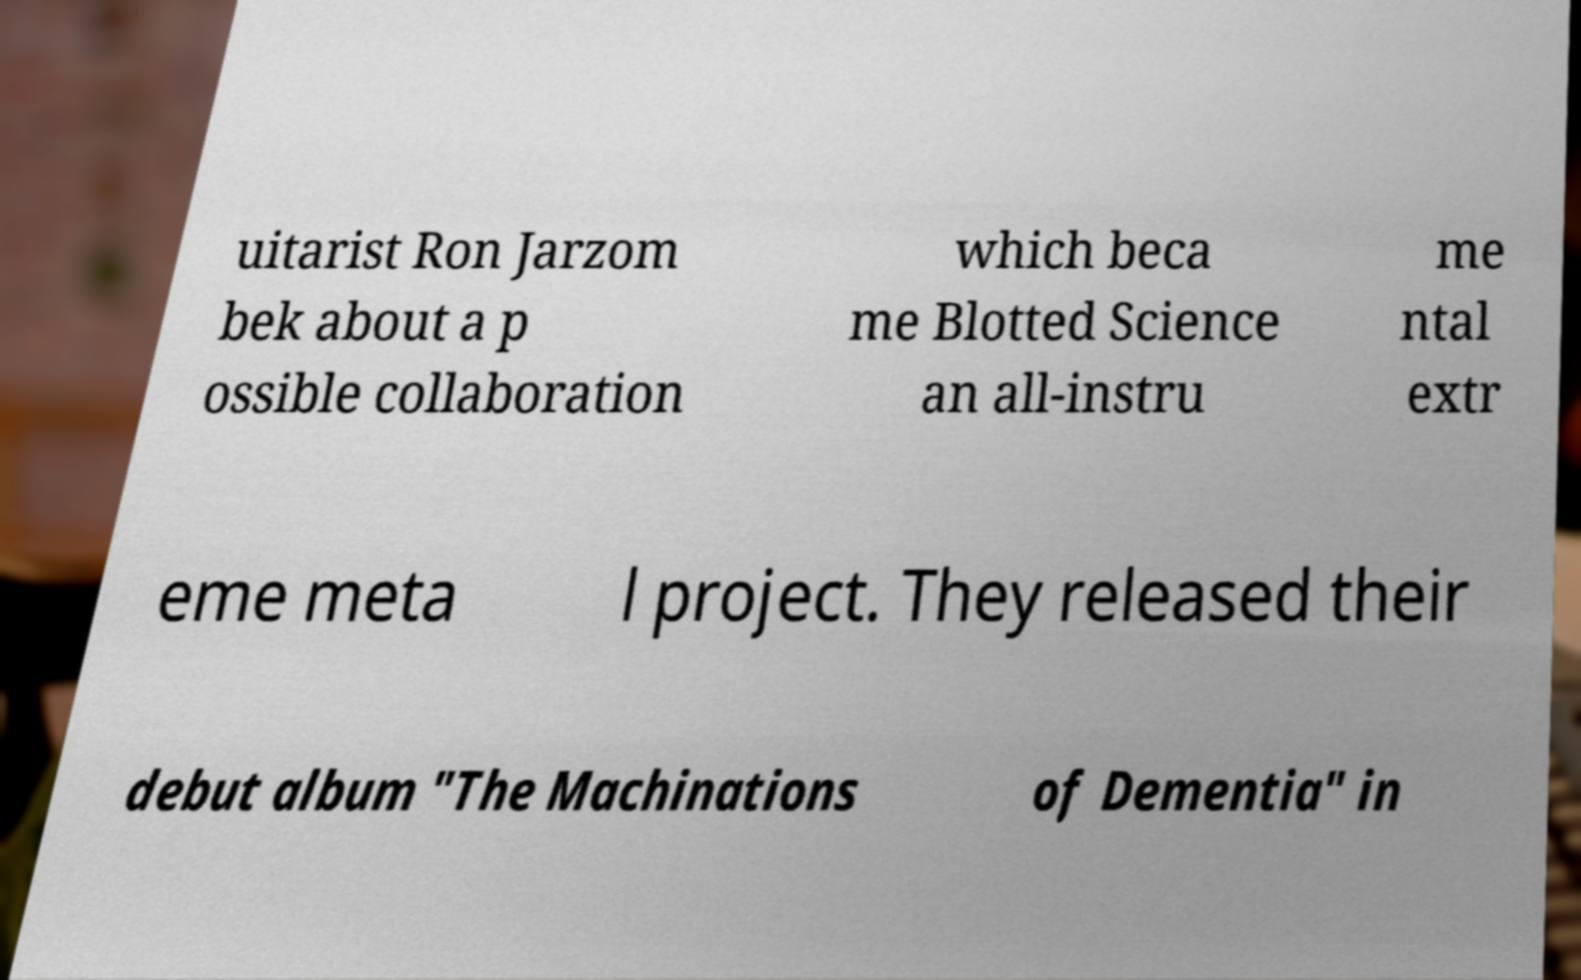Can you read and provide the text displayed in the image?This photo seems to have some interesting text. Can you extract and type it out for me? uitarist Ron Jarzom bek about a p ossible collaboration which beca me Blotted Science an all-instru me ntal extr eme meta l project. They released their debut album "The Machinations of Dementia" in 